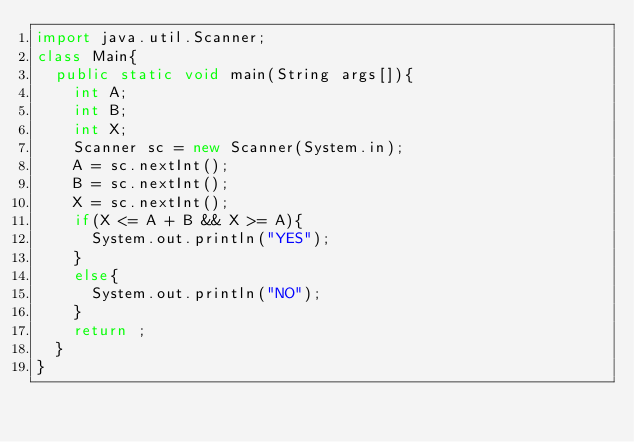<code> <loc_0><loc_0><loc_500><loc_500><_Java_>import java.util.Scanner;
class Main{
  public static void main(String args[]){
    int A;
    int B;
    int X;
    Scanner sc = new Scanner(System.in);
    A = sc.nextInt();
    B = sc.nextInt();
    X = sc.nextInt();
    if(X <= A + B && X >= A){
      System.out.println("YES");
    }
    else{
      System.out.println("NO");
    }
    return ;
  }
}
</code> 